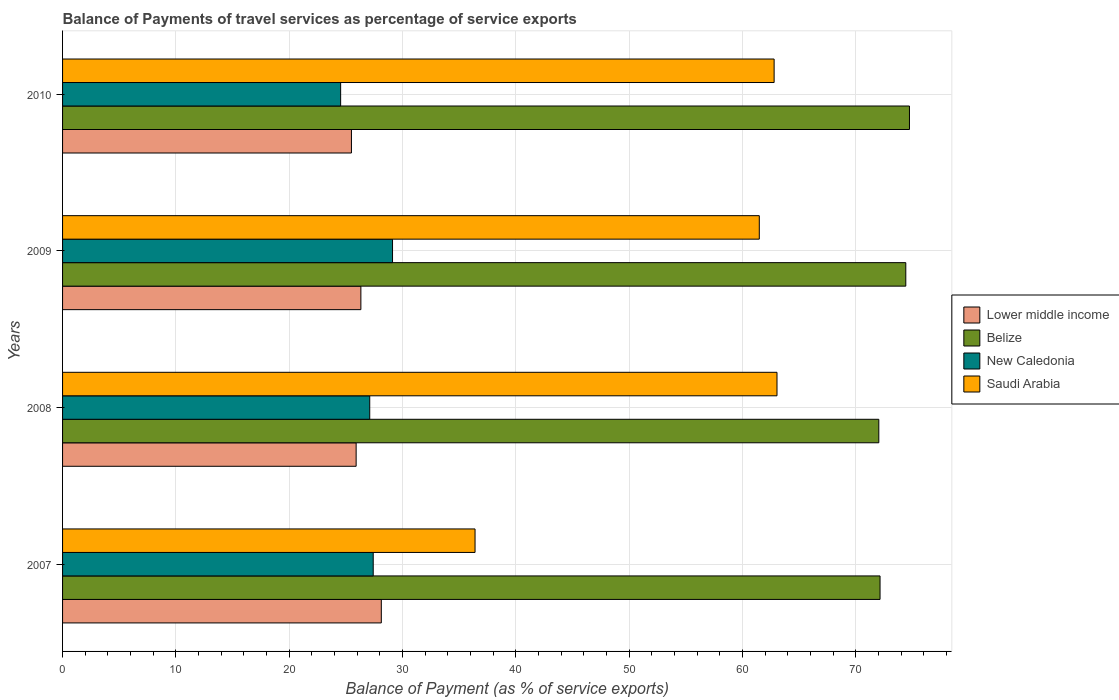How many different coloured bars are there?
Offer a very short reply. 4. How many groups of bars are there?
Provide a succinct answer. 4. Are the number of bars per tick equal to the number of legend labels?
Ensure brevity in your answer.  Yes. Are the number of bars on each tick of the Y-axis equal?
Offer a terse response. Yes. What is the label of the 1st group of bars from the top?
Make the answer very short. 2010. What is the balance of payments of travel services in New Caledonia in 2010?
Ensure brevity in your answer.  24.54. Across all years, what is the maximum balance of payments of travel services in New Caledonia?
Provide a succinct answer. 29.12. Across all years, what is the minimum balance of payments of travel services in Lower middle income?
Your answer should be very brief. 25.49. In which year was the balance of payments of travel services in Lower middle income minimum?
Keep it short and to the point. 2010. What is the total balance of payments of travel services in Lower middle income in the graph?
Provide a succinct answer. 105.86. What is the difference between the balance of payments of travel services in Saudi Arabia in 2007 and that in 2008?
Provide a short and direct response. -26.65. What is the difference between the balance of payments of travel services in Belize in 2010 and the balance of payments of travel services in New Caledonia in 2009?
Make the answer very short. 45.62. What is the average balance of payments of travel services in Belize per year?
Provide a succinct answer. 73.33. In the year 2009, what is the difference between the balance of payments of travel services in New Caledonia and balance of payments of travel services in Saudi Arabia?
Your answer should be very brief. -32.37. In how many years, is the balance of payments of travel services in New Caledonia greater than 58 %?
Offer a very short reply. 0. What is the ratio of the balance of payments of travel services in New Caledonia in 2008 to that in 2009?
Offer a terse response. 0.93. Is the difference between the balance of payments of travel services in New Caledonia in 2007 and 2008 greater than the difference between the balance of payments of travel services in Saudi Arabia in 2007 and 2008?
Provide a short and direct response. Yes. What is the difference between the highest and the second highest balance of payments of travel services in Lower middle income?
Provide a short and direct response. 1.8. What is the difference between the highest and the lowest balance of payments of travel services in Saudi Arabia?
Your answer should be very brief. 26.65. What does the 1st bar from the top in 2007 represents?
Provide a succinct answer. Saudi Arabia. What does the 3rd bar from the bottom in 2010 represents?
Your answer should be very brief. New Caledonia. How many bars are there?
Make the answer very short. 16. Are all the bars in the graph horizontal?
Your response must be concise. Yes. What is the difference between two consecutive major ticks on the X-axis?
Your response must be concise. 10. Does the graph contain grids?
Give a very brief answer. Yes. Where does the legend appear in the graph?
Offer a terse response. Center right. How many legend labels are there?
Offer a very short reply. 4. How are the legend labels stacked?
Offer a very short reply. Vertical. What is the title of the graph?
Provide a succinct answer. Balance of Payments of travel services as percentage of service exports. What is the label or title of the X-axis?
Your answer should be very brief. Balance of Payment (as % of service exports). What is the label or title of the Y-axis?
Provide a short and direct response. Years. What is the Balance of Payment (as % of service exports) in Lower middle income in 2007?
Your answer should be compact. 28.13. What is the Balance of Payment (as % of service exports) in Belize in 2007?
Your response must be concise. 72.14. What is the Balance of Payment (as % of service exports) in New Caledonia in 2007?
Provide a succinct answer. 27.42. What is the Balance of Payment (as % of service exports) of Saudi Arabia in 2007?
Provide a succinct answer. 36.4. What is the Balance of Payment (as % of service exports) of Lower middle income in 2008?
Your answer should be compact. 25.91. What is the Balance of Payment (as % of service exports) in Belize in 2008?
Your response must be concise. 72.03. What is the Balance of Payment (as % of service exports) in New Caledonia in 2008?
Give a very brief answer. 27.11. What is the Balance of Payment (as % of service exports) in Saudi Arabia in 2008?
Your answer should be compact. 63.05. What is the Balance of Payment (as % of service exports) of Lower middle income in 2009?
Ensure brevity in your answer.  26.33. What is the Balance of Payment (as % of service exports) of Belize in 2009?
Ensure brevity in your answer.  74.42. What is the Balance of Payment (as % of service exports) of New Caledonia in 2009?
Provide a succinct answer. 29.12. What is the Balance of Payment (as % of service exports) in Saudi Arabia in 2009?
Make the answer very short. 61.49. What is the Balance of Payment (as % of service exports) of Lower middle income in 2010?
Your response must be concise. 25.49. What is the Balance of Payment (as % of service exports) in Belize in 2010?
Your answer should be very brief. 74.74. What is the Balance of Payment (as % of service exports) in New Caledonia in 2010?
Offer a very short reply. 24.54. What is the Balance of Payment (as % of service exports) in Saudi Arabia in 2010?
Offer a very short reply. 62.8. Across all years, what is the maximum Balance of Payment (as % of service exports) of Lower middle income?
Give a very brief answer. 28.13. Across all years, what is the maximum Balance of Payment (as % of service exports) of Belize?
Make the answer very short. 74.74. Across all years, what is the maximum Balance of Payment (as % of service exports) of New Caledonia?
Your answer should be very brief. 29.12. Across all years, what is the maximum Balance of Payment (as % of service exports) in Saudi Arabia?
Provide a succinct answer. 63.05. Across all years, what is the minimum Balance of Payment (as % of service exports) in Lower middle income?
Ensure brevity in your answer.  25.49. Across all years, what is the minimum Balance of Payment (as % of service exports) in Belize?
Offer a terse response. 72.03. Across all years, what is the minimum Balance of Payment (as % of service exports) of New Caledonia?
Provide a short and direct response. 24.54. Across all years, what is the minimum Balance of Payment (as % of service exports) in Saudi Arabia?
Ensure brevity in your answer.  36.4. What is the total Balance of Payment (as % of service exports) in Lower middle income in the graph?
Offer a very short reply. 105.86. What is the total Balance of Payment (as % of service exports) in Belize in the graph?
Offer a terse response. 293.34. What is the total Balance of Payment (as % of service exports) in New Caledonia in the graph?
Keep it short and to the point. 108.18. What is the total Balance of Payment (as % of service exports) in Saudi Arabia in the graph?
Give a very brief answer. 223.74. What is the difference between the Balance of Payment (as % of service exports) in Lower middle income in 2007 and that in 2008?
Provide a short and direct response. 2.22. What is the difference between the Balance of Payment (as % of service exports) of Belize in 2007 and that in 2008?
Provide a succinct answer. 0.11. What is the difference between the Balance of Payment (as % of service exports) in New Caledonia in 2007 and that in 2008?
Provide a succinct answer. 0.31. What is the difference between the Balance of Payment (as % of service exports) in Saudi Arabia in 2007 and that in 2008?
Offer a terse response. -26.65. What is the difference between the Balance of Payment (as % of service exports) in Lower middle income in 2007 and that in 2009?
Provide a succinct answer. 1.8. What is the difference between the Balance of Payment (as % of service exports) of Belize in 2007 and that in 2009?
Keep it short and to the point. -2.27. What is the difference between the Balance of Payment (as % of service exports) of New Caledonia in 2007 and that in 2009?
Ensure brevity in your answer.  -1.7. What is the difference between the Balance of Payment (as % of service exports) of Saudi Arabia in 2007 and that in 2009?
Give a very brief answer. -25.09. What is the difference between the Balance of Payment (as % of service exports) in Lower middle income in 2007 and that in 2010?
Make the answer very short. 2.64. What is the difference between the Balance of Payment (as % of service exports) in Belize in 2007 and that in 2010?
Provide a short and direct response. -2.6. What is the difference between the Balance of Payment (as % of service exports) in New Caledonia in 2007 and that in 2010?
Your answer should be compact. 2.88. What is the difference between the Balance of Payment (as % of service exports) of Saudi Arabia in 2007 and that in 2010?
Offer a very short reply. -26.39. What is the difference between the Balance of Payment (as % of service exports) in Lower middle income in 2008 and that in 2009?
Your response must be concise. -0.42. What is the difference between the Balance of Payment (as % of service exports) of Belize in 2008 and that in 2009?
Your answer should be very brief. -2.38. What is the difference between the Balance of Payment (as % of service exports) in New Caledonia in 2008 and that in 2009?
Your response must be concise. -2.01. What is the difference between the Balance of Payment (as % of service exports) of Saudi Arabia in 2008 and that in 2009?
Offer a very short reply. 1.56. What is the difference between the Balance of Payment (as % of service exports) of Lower middle income in 2008 and that in 2010?
Provide a short and direct response. 0.42. What is the difference between the Balance of Payment (as % of service exports) of Belize in 2008 and that in 2010?
Provide a short and direct response. -2.71. What is the difference between the Balance of Payment (as % of service exports) in New Caledonia in 2008 and that in 2010?
Offer a very short reply. 2.57. What is the difference between the Balance of Payment (as % of service exports) in Saudi Arabia in 2008 and that in 2010?
Your response must be concise. 0.25. What is the difference between the Balance of Payment (as % of service exports) in Lower middle income in 2009 and that in 2010?
Your answer should be compact. 0.83. What is the difference between the Balance of Payment (as % of service exports) in Belize in 2009 and that in 2010?
Provide a succinct answer. -0.32. What is the difference between the Balance of Payment (as % of service exports) of New Caledonia in 2009 and that in 2010?
Offer a terse response. 4.58. What is the difference between the Balance of Payment (as % of service exports) in Saudi Arabia in 2009 and that in 2010?
Provide a succinct answer. -1.31. What is the difference between the Balance of Payment (as % of service exports) in Lower middle income in 2007 and the Balance of Payment (as % of service exports) in Belize in 2008?
Give a very brief answer. -43.9. What is the difference between the Balance of Payment (as % of service exports) in Lower middle income in 2007 and the Balance of Payment (as % of service exports) in New Caledonia in 2008?
Provide a succinct answer. 1.02. What is the difference between the Balance of Payment (as % of service exports) of Lower middle income in 2007 and the Balance of Payment (as % of service exports) of Saudi Arabia in 2008?
Make the answer very short. -34.92. What is the difference between the Balance of Payment (as % of service exports) of Belize in 2007 and the Balance of Payment (as % of service exports) of New Caledonia in 2008?
Ensure brevity in your answer.  45.04. What is the difference between the Balance of Payment (as % of service exports) in Belize in 2007 and the Balance of Payment (as % of service exports) in Saudi Arabia in 2008?
Keep it short and to the point. 9.09. What is the difference between the Balance of Payment (as % of service exports) of New Caledonia in 2007 and the Balance of Payment (as % of service exports) of Saudi Arabia in 2008?
Your answer should be compact. -35.63. What is the difference between the Balance of Payment (as % of service exports) of Lower middle income in 2007 and the Balance of Payment (as % of service exports) of Belize in 2009?
Your answer should be compact. -46.29. What is the difference between the Balance of Payment (as % of service exports) of Lower middle income in 2007 and the Balance of Payment (as % of service exports) of New Caledonia in 2009?
Your answer should be compact. -0.99. What is the difference between the Balance of Payment (as % of service exports) of Lower middle income in 2007 and the Balance of Payment (as % of service exports) of Saudi Arabia in 2009?
Your answer should be very brief. -33.36. What is the difference between the Balance of Payment (as % of service exports) of Belize in 2007 and the Balance of Payment (as % of service exports) of New Caledonia in 2009?
Your response must be concise. 43.02. What is the difference between the Balance of Payment (as % of service exports) of Belize in 2007 and the Balance of Payment (as % of service exports) of Saudi Arabia in 2009?
Provide a succinct answer. 10.66. What is the difference between the Balance of Payment (as % of service exports) of New Caledonia in 2007 and the Balance of Payment (as % of service exports) of Saudi Arabia in 2009?
Ensure brevity in your answer.  -34.07. What is the difference between the Balance of Payment (as % of service exports) of Lower middle income in 2007 and the Balance of Payment (as % of service exports) of Belize in 2010?
Ensure brevity in your answer.  -46.61. What is the difference between the Balance of Payment (as % of service exports) in Lower middle income in 2007 and the Balance of Payment (as % of service exports) in New Caledonia in 2010?
Your response must be concise. 3.59. What is the difference between the Balance of Payment (as % of service exports) of Lower middle income in 2007 and the Balance of Payment (as % of service exports) of Saudi Arabia in 2010?
Your answer should be compact. -34.67. What is the difference between the Balance of Payment (as % of service exports) of Belize in 2007 and the Balance of Payment (as % of service exports) of New Caledonia in 2010?
Provide a short and direct response. 47.6. What is the difference between the Balance of Payment (as % of service exports) of Belize in 2007 and the Balance of Payment (as % of service exports) of Saudi Arabia in 2010?
Your answer should be compact. 9.35. What is the difference between the Balance of Payment (as % of service exports) in New Caledonia in 2007 and the Balance of Payment (as % of service exports) in Saudi Arabia in 2010?
Make the answer very short. -35.38. What is the difference between the Balance of Payment (as % of service exports) of Lower middle income in 2008 and the Balance of Payment (as % of service exports) of Belize in 2009?
Keep it short and to the point. -48.51. What is the difference between the Balance of Payment (as % of service exports) of Lower middle income in 2008 and the Balance of Payment (as % of service exports) of New Caledonia in 2009?
Your answer should be compact. -3.21. What is the difference between the Balance of Payment (as % of service exports) of Lower middle income in 2008 and the Balance of Payment (as % of service exports) of Saudi Arabia in 2009?
Offer a terse response. -35.58. What is the difference between the Balance of Payment (as % of service exports) in Belize in 2008 and the Balance of Payment (as % of service exports) in New Caledonia in 2009?
Provide a short and direct response. 42.92. What is the difference between the Balance of Payment (as % of service exports) in Belize in 2008 and the Balance of Payment (as % of service exports) in Saudi Arabia in 2009?
Provide a short and direct response. 10.55. What is the difference between the Balance of Payment (as % of service exports) in New Caledonia in 2008 and the Balance of Payment (as % of service exports) in Saudi Arabia in 2009?
Provide a short and direct response. -34.38. What is the difference between the Balance of Payment (as % of service exports) in Lower middle income in 2008 and the Balance of Payment (as % of service exports) in Belize in 2010?
Offer a terse response. -48.83. What is the difference between the Balance of Payment (as % of service exports) of Lower middle income in 2008 and the Balance of Payment (as % of service exports) of New Caledonia in 2010?
Give a very brief answer. 1.37. What is the difference between the Balance of Payment (as % of service exports) in Lower middle income in 2008 and the Balance of Payment (as % of service exports) in Saudi Arabia in 2010?
Your response must be concise. -36.89. What is the difference between the Balance of Payment (as % of service exports) of Belize in 2008 and the Balance of Payment (as % of service exports) of New Caledonia in 2010?
Ensure brevity in your answer.  47.49. What is the difference between the Balance of Payment (as % of service exports) in Belize in 2008 and the Balance of Payment (as % of service exports) in Saudi Arabia in 2010?
Your answer should be compact. 9.24. What is the difference between the Balance of Payment (as % of service exports) in New Caledonia in 2008 and the Balance of Payment (as % of service exports) in Saudi Arabia in 2010?
Provide a short and direct response. -35.69. What is the difference between the Balance of Payment (as % of service exports) in Lower middle income in 2009 and the Balance of Payment (as % of service exports) in Belize in 2010?
Give a very brief answer. -48.41. What is the difference between the Balance of Payment (as % of service exports) in Lower middle income in 2009 and the Balance of Payment (as % of service exports) in New Caledonia in 2010?
Ensure brevity in your answer.  1.79. What is the difference between the Balance of Payment (as % of service exports) of Lower middle income in 2009 and the Balance of Payment (as % of service exports) of Saudi Arabia in 2010?
Your response must be concise. -36.47. What is the difference between the Balance of Payment (as % of service exports) of Belize in 2009 and the Balance of Payment (as % of service exports) of New Caledonia in 2010?
Provide a succinct answer. 49.88. What is the difference between the Balance of Payment (as % of service exports) in Belize in 2009 and the Balance of Payment (as % of service exports) in Saudi Arabia in 2010?
Your answer should be very brief. 11.62. What is the difference between the Balance of Payment (as % of service exports) in New Caledonia in 2009 and the Balance of Payment (as % of service exports) in Saudi Arabia in 2010?
Make the answer very short. -33.68. What is the average Balance of Payment (as % of service exports) in Lower middle income per year?
Your response must be concise. 26.46. What is the average Balance of Payment (as % of service exports) in Belize per year?
Your answer should be very brief. 73.33. What is the average Balance of Payment (as % of service exports) of New Caledonia per year?
Provide a short and direct response. 27.05. What is the average Balance of Payment (as % of service exports) in Saudi Arabia per year?
Make the answer very short. 55.93. In the year 2007, what is the difference between the Balance of Payment (as % of service exports) of Lower middle income and Balance of Payment (as % of service exports) of Belize?
Offer a very short reply. -44.01. In the year 2007, what is the difference between the Balance of Payment (as % of service exports) in Lower middle income and Balance of Payment (as % of service exports) in New Caledonia?
Offer a terse response. 0.71. In the year 2007, what is the difference between the Balance of Payment (as % of service exports) of Lower middle income and Balance of Payment (as % of service exports) of Saudi Arabia?
Make the answer very short. -8.27. In the year 2007, what is the difference between the Balance of Payment (as % of service exports) of Belize and Balance of Payment (as % of service exports) of New Caledonia?
Make the answer very short. 44.73. In the year 2007, what is the difference between the Balance of Payment (as % of service exports) in Belize and Balance of Payment (as % of service exports) in Saudi Arabia?
Give a very brief answer. 35.74. In the year 2007, what is the difference between the Balance of Payment (as % of service exports) in New Caledonia and Balance of Payment (as % of service exports) in Saudi Arabia?
Keep it short and to the point. -8.99. In the year 2008, what is the difference between the Balance of Payment (as % of service exports) in Lower middle income and Balance of Payment (as % of service exports) in Belize?
Your response must be concise. -46.13. In the year 2008, what is the difference between the Balance of Payment (as % of service exports) of Lower middle income and Balance of Payment (as % of service exports) of New Caledonia?
Your answer should be very brief. -1.2. In the year 2008, what is the difference between the Balance of Payment (as % of service exports) in Lower middle income and Balance of Payment (as % of service exports) in Saudi Arabia?
Your response must be concise. -37.14. In the year 2008, what is the difference between the Balance of Payment (as % of service exports) in Belize and Balance of Payment (as % of service exports) in New Caledonia?
Your answer should be compact. 44.93. In the year 2008, what is the difference between the Balance of Payment (as % of service exports) of Belize and Balance of Payment (as % of service exports) of Saudi Arabia?
Offer a very short reply. 8.99. In the year 2008, what is the difference between the Balance of Payment (as % of service exports) in New Caledonia and Balance of Payment (as % of service exports) in Saudi Arabia?
Your response must be concise. -35.94. In the year 2009, what is the difference between the Balance of Payment (as % of service exports) in Lower middle income and Balance of Payment (as % of service exports) in Belize?
Ensure brevity in your answer.  -48.09. In the year 2009, what is the difference between the Balance of Payment (as % of service exports) in Lower middle income and Balance of Payment (as % of service exports) in New Caledonia?
Offer a terse response. -2.79. In the year 2009, what is the difference between the Balance of Payment (as % of service exports) of Lower middle income and Balance of Payment (as % of service exports) of Saudi Arabia?
Give a very brief answer. -35.16. In the year 2009, what is the difference between the Balance of Payment (as % of service exports) in Belize and Balance of Payment (as % of service exports) in New Caledonia?
Provide a succinct answer. 45.3. In the year 2009, what is the difference between the Balance of Payment (as % of service exports) in Belize and Balance of Payment (as % of service exports) in Saudi Arabia?
Provide a succinct answer. 12.93. In the year 2009, what is the difference between the Balance of Payment (as % of service exports) of New Caledonia and Balance of Payment (as % of service exports) of Saudi Arabia?
Your response must be concise. -32.37. In the year 2010, what is the difference between the Balance of Payment (as % of service exports) in Lower middle income and Balance of Payment (as % of service exports) in Belize?
Ensure brevity in your answer.  -49.25. In the year 2010, what is the difference between the Balance of Payment (as % of service exports) of Lower middle income and Balance of Payment (as % of service exports) of New Caledonia?
Give a very brief answer. 0.95. In the year 2010, what is the difference between the Balance of Payment (as % of service exports) of Lower middle income and Balance of Payment (as % of service exports) of Saudi Arabia?
Your response must be concise. -37.3. In the year 2010, what is the difference between the Balance of Payment (as % of service exports) of Belize and Balance of Payment (as % of service exports) of New Caledonia?
Your answer should be very brief. 50.2. In the year 2010, what is the difference between the Balance of Payment (as % of service exports) of Belize and Balance of Payment (as % of service exports) of Saudi Arabia?
Your response must be concise. 11.94. In the year 2010, what is the difference between the Balance of Payment (as % of service exports) in New Caledonia and Balance of Payment (as % of service exports) in Saudi Arabia?
Offer a terse response. -38.26. What is the ratio of the Balance of Payment (as % of service exports) in Lower middle income in 2007 to that in 2008?
Your answer should be very brief. 1.09. What is the ratio of the Balance of Payment (as % of service exports) of Belize in 2007 to that in 2008?
Make the answer very short. 1. What is the ratio of the Balance of Payment (as % of service exports) of New Caledonia in 2007 to that in 2008?
Your response must be concise. 1.01. What is the ratio of the Balance of Payment (as % of service exports) of Saudi Arabia in 2007 to that in 2008?
Keep it short and to the point. 0.58. What is the ratio of the Balance of Payment (as % of service exports) in Lower middle income in 2007 to that in 2009?
Give a very brief answer. 1.07. What is the ratio of the Balance of Payment (as % of service exports) in Belize in 2007 to that in 2009?
Your answer should be very brief. 0.97. What is the ratio of the Balance of Payment (as % of service exports) of New Caledonia in 2007 to that in 2009?
Provide a succinct answer. 0.94. What is the ratio of the Balance of Payment (as % of service exports) of Saudi Arabia in 2007 to that in 2009?
Offer a very short reply. 0.59. What is the ratio of the Balance of Payment (as % of service exports) of Lower middle income in 2007 to that in 2010?
Keep it short and to the point. 1.1. What is the ratio of the Balance of Payment (as % of service exports) of Belize in 2007 to that in 2010?
Provide a short and direct response. 0.97. What is the ratio of the Balance of Payment (as % of service exports) in New Caledonia in 2007 to that in 2010?
Ensure brevity in your answer.  1.12. What is the ratio of the Balance of Payment (as % of service exports) of Saudi Arabia in 2007 to that in 2010?
Offer a very short reply. 0.58. What is the ratio of the Balance of Payment (as % of service exports) of Lower middle income in 2008 to that in 2009?
Provide a short and direct response. 0.98. What is the ratio of the Balance of Payment (as % of service exports) in New Caledonia in 2008 to that in 2009?
Offer a very short reply. 0.93. What is the ratio of the Balance of Payment (as % of service exports) in Saudi Arabia in 2008 to that in 2009?
Make the answer very short. 1.03. What is the ratio of the Balance of Payment (as % of service exports) in Lower middle income in 2008 to that in 2010?
Your answer should be compact. 1.02. What is the ratio of the Balance of Payment (as % of service exports) in Belize in 2008 to that in 2010?
Your answer should be very brief. 0.96. What is the ratio of the Balance of Payment (as % of service exports) in New Caledonia in 2008 to that in 2010?
Your response must be concise. 1.1. What is the ratio of the Balance of Payment (as % of service exports) of Saudi Arabia in 2008 to that in 2010?
Provide a short and direct response. 1. What is the ratio of the Balance of Payment (as % of service exports) of Lower middle income in 2009 to that in 2010?
Your answer should be compact. 1.03. What is the ratio of the Balance of Payment (as % of service exports) of New Caledonia in 2009 to that in 2010?
Ensure brevity in your answer.  1.19. What is the ratio of the Balance of Payment (as % of service exports) of Saudi Arabia in 2009 to that in 2010?
Offer a terse response. 0.98. What is the difference between the highest and the second highest Balance of Payment (as % of service exports) of Lower middle income?
Give a very brief answer. 1.8. What is the difference between the highest and the second highest Balance of Payment (as % of service exports) of Belize?
Make the answer very short. 0.32. What is the difference between the highest and the second highest Balance of Payment (as % of service exports) of New Caledonia?
Provide a succinct answer. 1.7. What is the difference between the highest and the second highest Balance of Payment (as % of service exports) in Saudi Arabia?
Give a very brief answer. 0.25. What is the difference between the highest and the lowest Balance of Payment (as % of service exports) in Lower middle income?
Make the answer very short. 2.64. What is the difference between the highest and the lowest Balance of Payment (as % of service exports) in Belize?
Give a very brief answer. 2.71. What is the difference between the highest and the lowest Balance of Payment (as % of service exports) of New Caledonia?
Ensure brevity in your answer.  4.58. What is the difference between the highest and the lowest Balance of Payment (as % of service exports) in Saudi Arabia?
Provide a succinct answer. 26.65. 